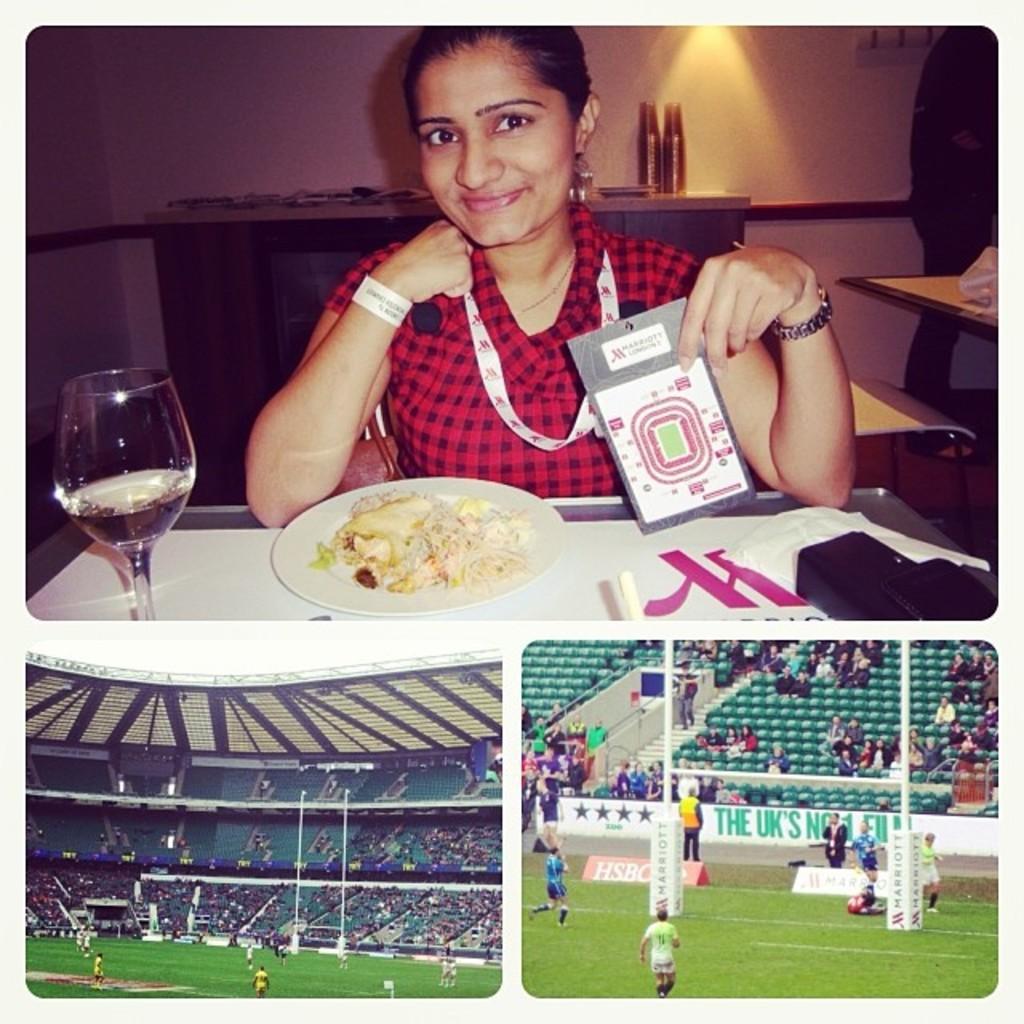How would you summarize this image in a sentence or two? In the picture we can see three photographs, in the first image we can see a woman sitting in the chair near the table, on the table we can see a plate of food and beside we can see a glass of water and she is holding her ID card with a tag and in the second image we can see a stadium with grass surface and players and full of audience and in the third image also we can see a stadium from close. 